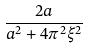<formula> <loc_0><loc_0><loc_500><loc_500>\frac { 2 a } { a ^ { 2 } + 4 \pi ^ { 2 } \xi ^ { 2 } }</formula> 